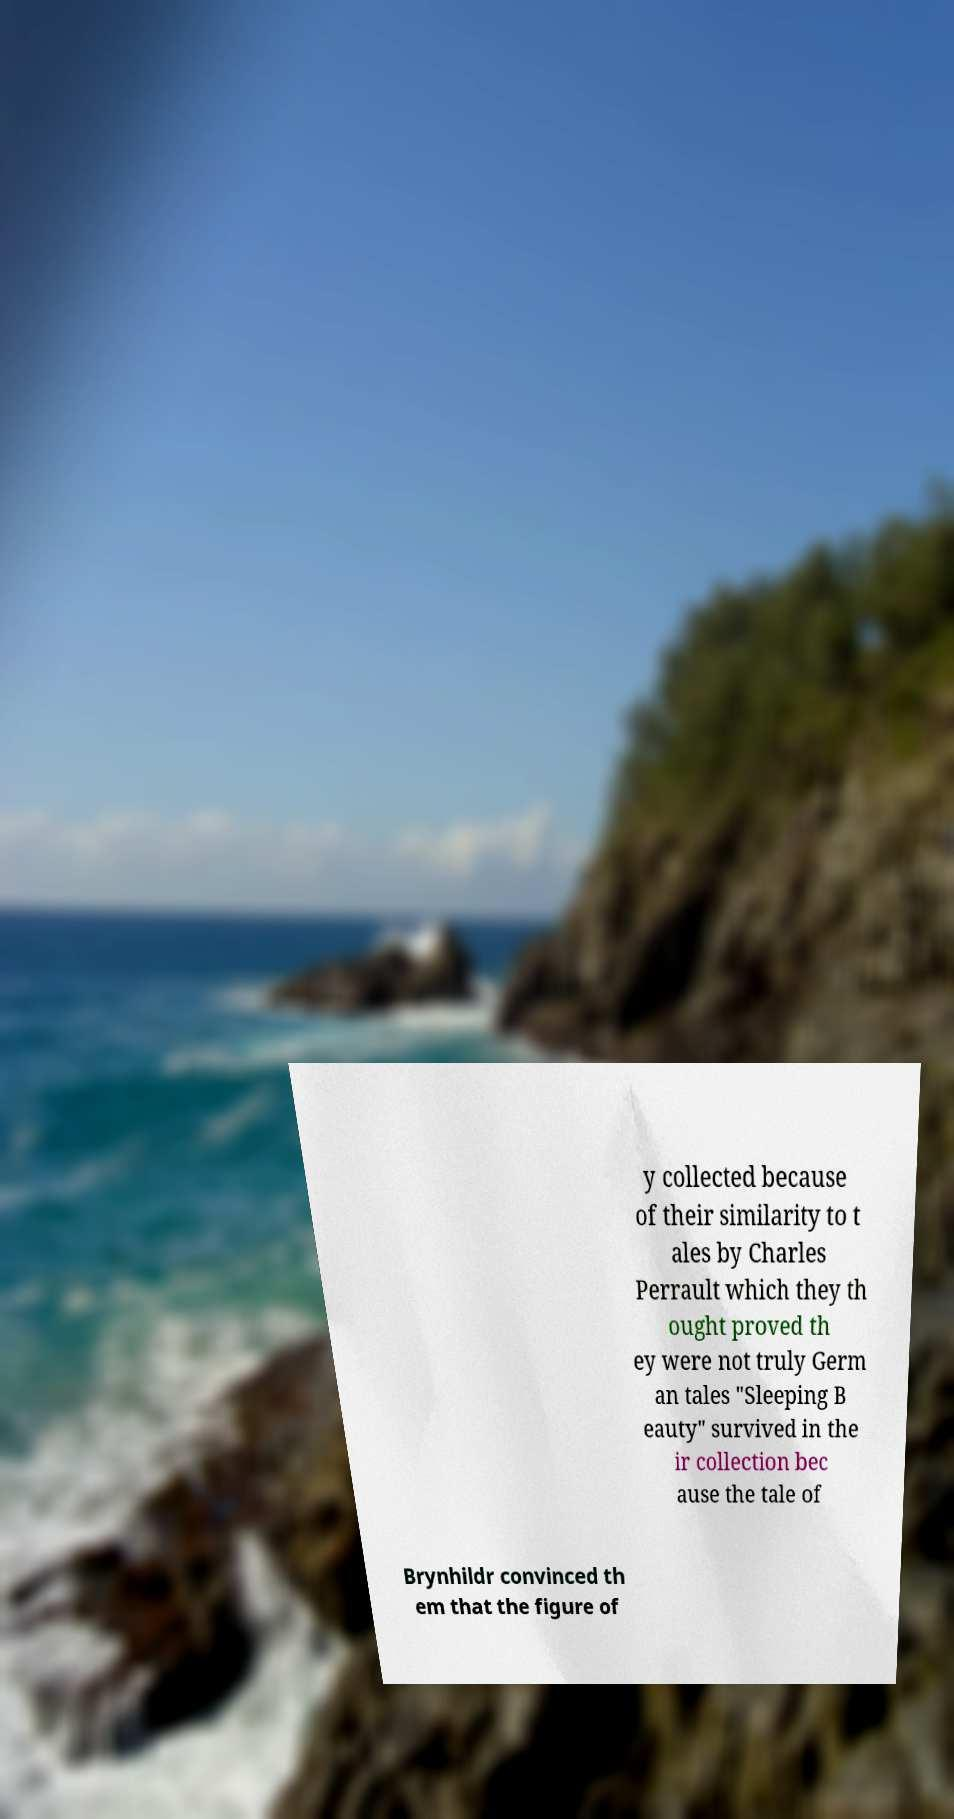I need the written content from this picture converted into text. Can you do that? y collected because of their similarity to t ales by Charles Perrault which they th ought proved th ey were not truly Germ an tales "Sleeping B eauty" survived in the ir collection bec ause the tale of Brynhildr convinced th em that the figure of 